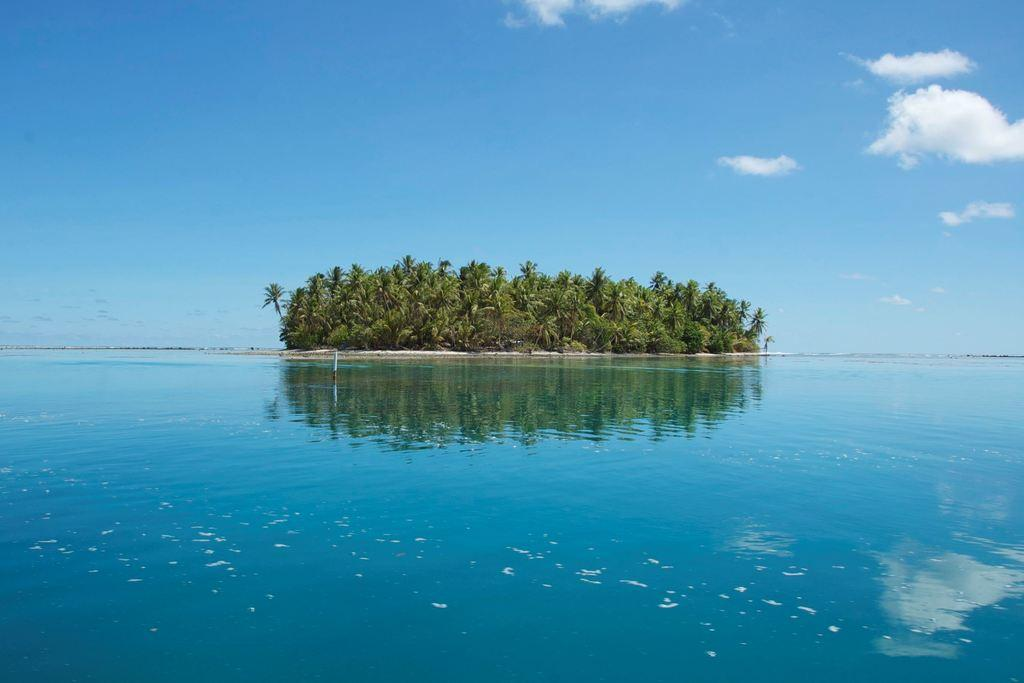What is the main feature of the image? The main feature of the image is an ocean. What can be found in the middle of the ocean? There is an island in the middle of the ocean. What type of vegetation is present on the island? There are trees on the island. What type of horn can be heard coming from the island in the image? There is no horn present in the image, and therefore no sound can be heard coming from the island. 